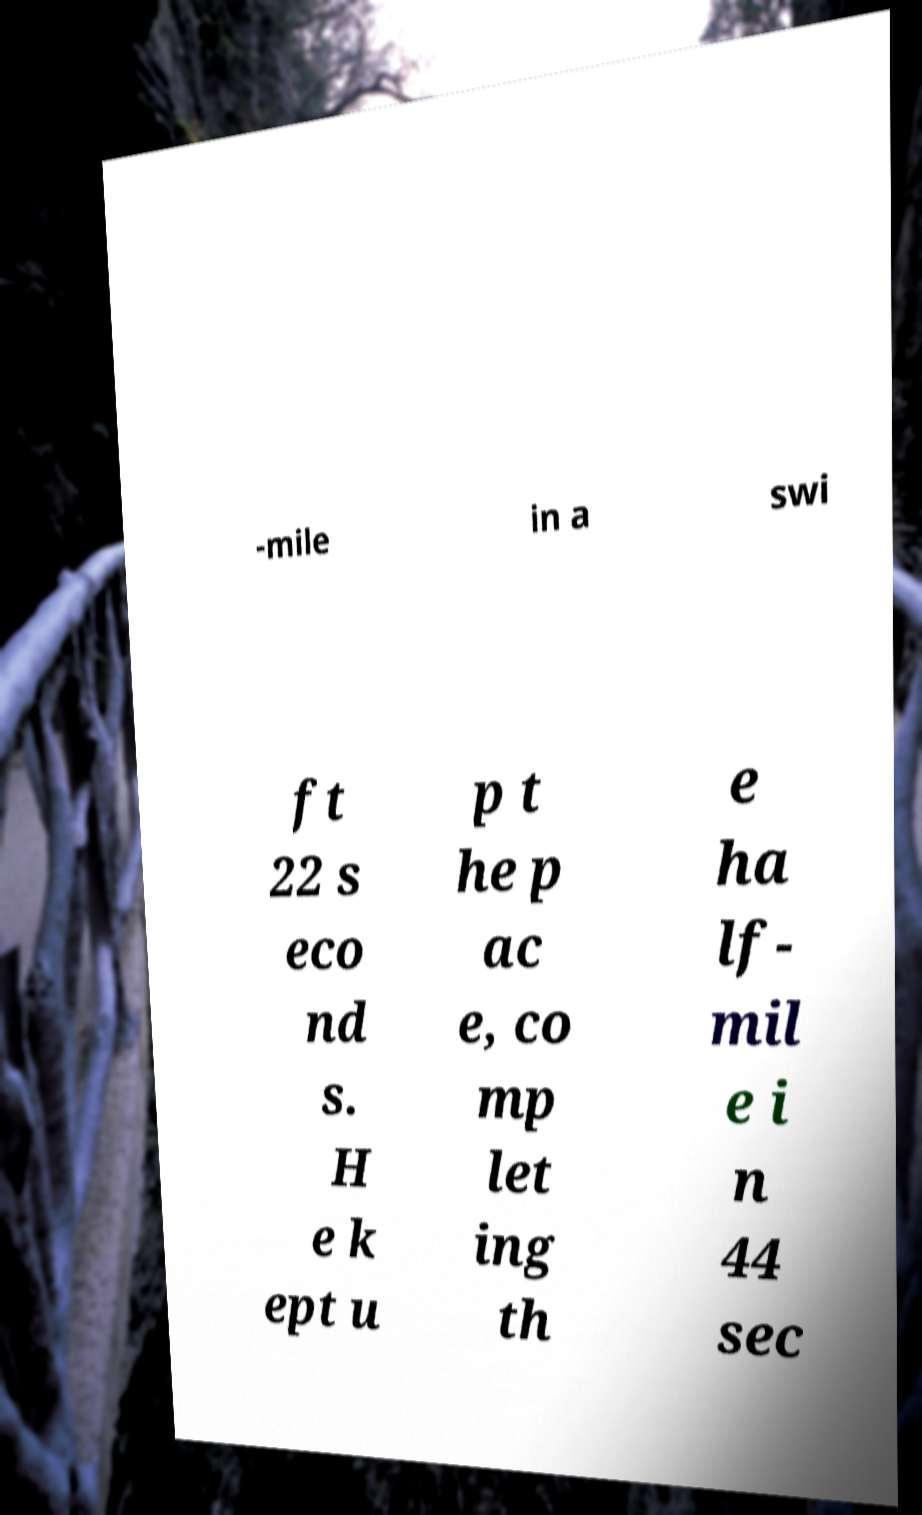I need the written content from this picture converted into text. Can you do that? -mile in a swi ft 22 s eco nd s. H e k ept u p t he p ac e, co mp let ing th e ha lf- mil e i n 44 sec 